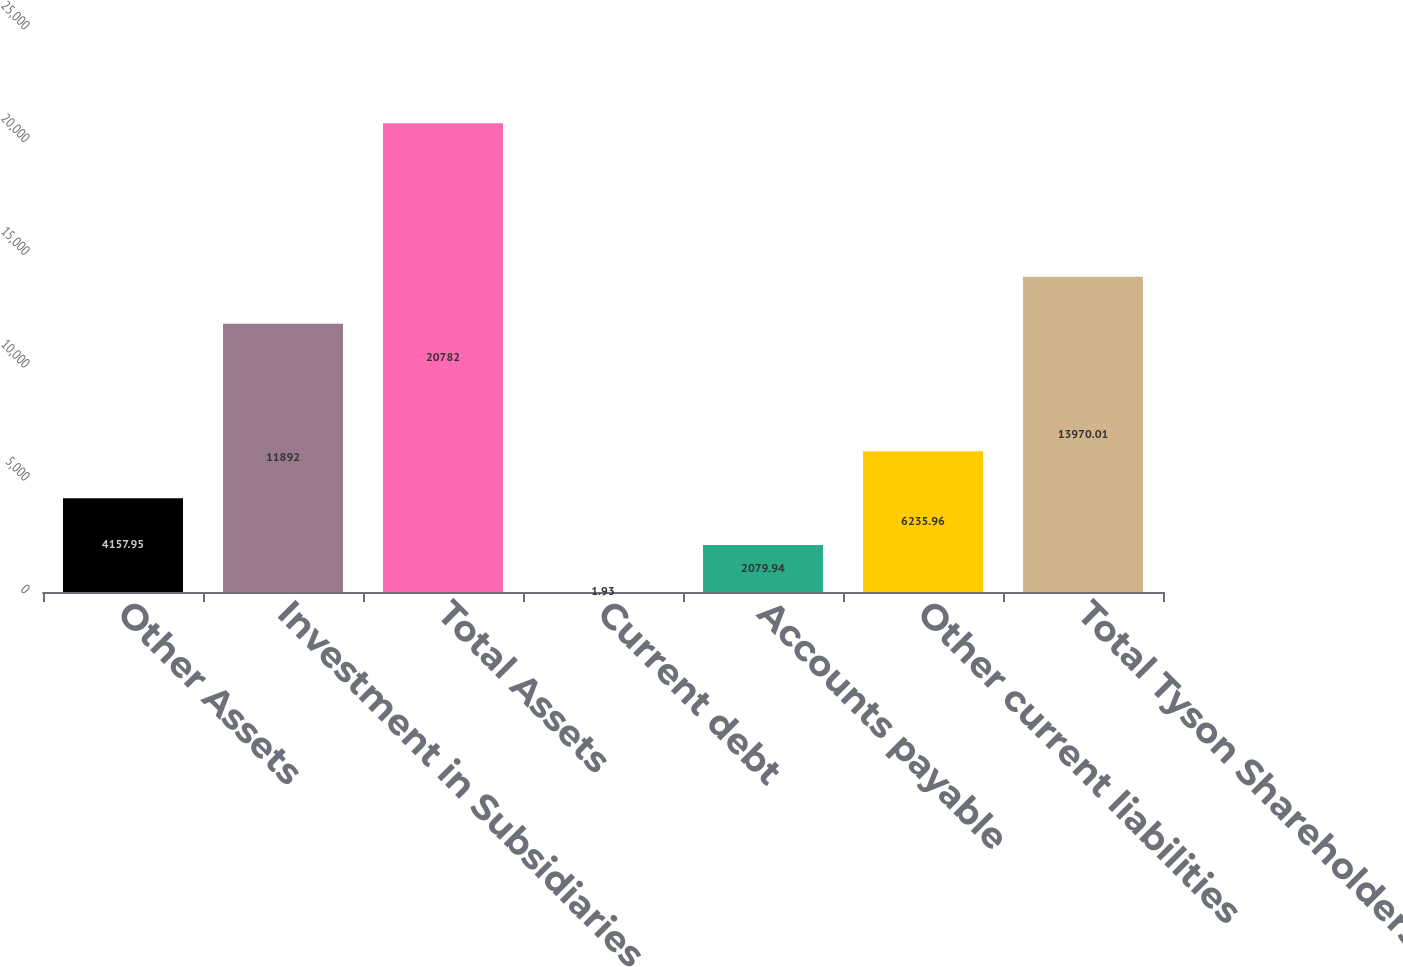Convert chart. <chart><loc_0><loc_0><loc_500><loc_500><bar_chart><fcel>Other Assets<fcel>Investment in Subsidiaries<fcel>Total Assets<fcel>Current debt<fcel>Accounts payable<fcel>Other current liabilities<fcel>Total Tyson Shareholders'<nl><fcel>4157.95<fcel>11892<fcel>20782<fcel>1.93<fcel>2079.94<fcel>6235.96<fcel>13970<nl></chart> 